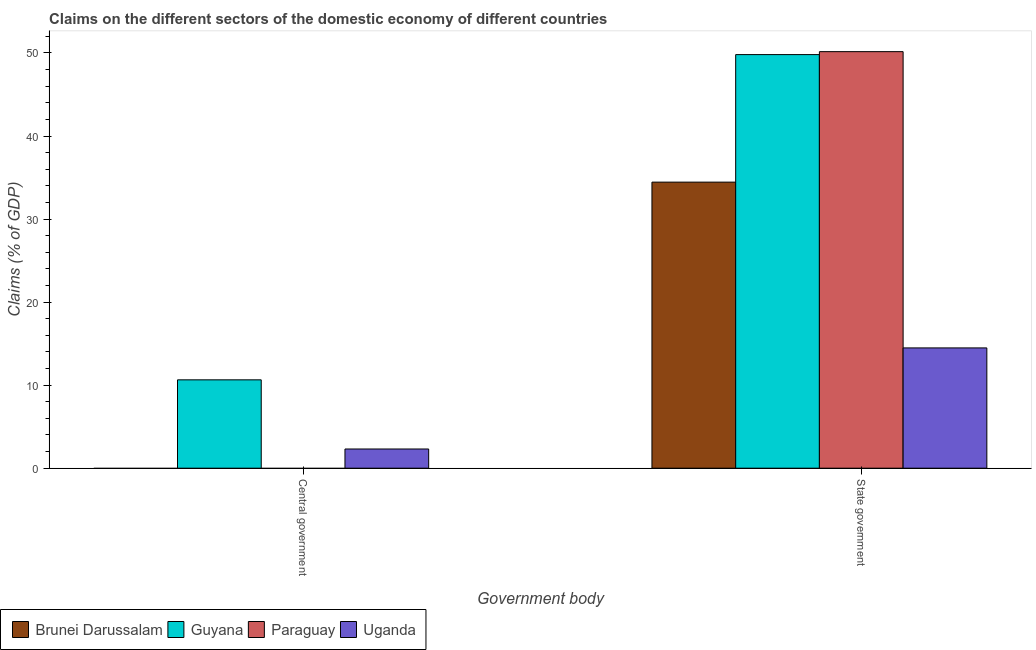How many different coloured bars are there?
Provide a short and direct response. 4. Are the number of bars per tick equal to the number of legend labels?
Your response must be concise. No. Are the number of bars on each tick of the X-axis equal?
Ensure brevity in your answer.  No. What is the label of the 2nd group of bars from the left?
Keep it short and to the point. State government. What is the claims on central government in Guyana?
Make the answer very short. 10.64. Across all countries, what is the maximum claims on state government?
Your answer should be very brief. 50.16. In which country was the claims on state government maximum?
Your answer should be very brief. Paraguay. What is the total claims on central government in the graph?
Keep it short and to the point. 12.95. What is the difference between the claims on central government in Uganda and that in Guyana?
Your answer should be compact. -8.33. What is the difference between the claims on state government in Paraguay and the claims on central government in Brunei Darussalam?
Your answer should be very brief. 50.16. What is the average claims on state government per country?
Your answer should be very brief. 37.22. What is the difference between the claims on state government and claims on central government in Guyana?
Provide a short and direct response. 39.16. What is the ratio of the claims on state government in Uganda to that in Guyana?
Make the answer very short. 0.29. How many bars are there?
Provide a succinct answer. 6. What is the difference between two consecutive major ticks on the Y-axis?
Make the answer very short. 10. What is the title of the graph?
Provide a short and direct response. Claims on the different sectors of the domestic economy of different countries. Does "Euro area" appear as one of the legend labels in the graph?
Give a very brief answer. No. What is the label or title of the X-axis?
Your answer should be very brief. Government body. What is the label or title of the Y-axis?
Provide a short and direct response. Claims (% of GDP). What is the Claims (% of GDP) in Brunei Darussalam in Central government?
Your response must be concise. 0. What is the Claims (% of GDP) of Guyana in Central government?
Give a very brief answer. 10.64. What is the Claims (% of GDP) of Uganda in Central government?
Keep it short and to the point. 2.31. What is the Claims (% of GDP) of Brunei Darussalam in State government?
Offer a very short reply. 34.44. What is the Claims (% of GDP) of Guyana in State government?
Offer a very short reply. 49.8. What is the Claims (% of GDP) of Paraguay in State government?
Make the answer very short. 50.16. What is the Claims (% of GDP) in Uganda in State government?
Your answer should be compact. 14.48. Across all Government body, what is the maximum Claims (% of GDP) in Brunei Darussalam?
Provide a short and direct response. 34.44. Across all Government body, what is the maximum Claims (% of GDP) in Guyana?
Keep it short and to the point. 49.8. Across all Government body, what is the maximum Claims (% of GDP) of Paraguay?
Keep it short and to the point. 50.16. Across all Government body, what is the maximum Claims (% of GDP) of Uganda?
Ensure brevity in your answer.  14.48. Across all Government body, what is the minimum Claims (% of GDP) of Guyana?
Give a very brief answer. 10.64. Across all Government body, what is the minimum Claims (% of GDP) of Uganda?
Offer a very short reply. 2.31. What is the total Claims (% of GDP) of Brunei Darussalam in the graph?
Your response must be concise. 34.44. What is the total Claims (% of GDP) in Guyana in the graph?
Offer a very short reply. 60.44. What is the total Claims (% of GDP) of Paraguay in the graph?
Offer a terse response. 50.16. What is the total Claims (% of GDP) in Uganda in the graph?
Make the answer very short. 16.8. What is the difference between the Claims (% of GDP) of Guyana in Central government and that in State government?
Your response must be concise. -39.16. What is the difference between the Claims (% of GDP) of Uganda in Central government and that in State government?
Your answer should be very brief. -12.17. What is the difference between the Claims (% of GDP) of Guyana in Central government and the Claims (% of GDP) of Paraguay in State government?
Your answer should be very brief. -39.52. What is the difference between the Claims (% of GDP) in Guyana in Central government and the Claims (% of GDP) in Uganda in State government?
Provide a short and direct response. -3.84. What is the average Claims (% of GDP) of Brunei Darussalam per Government body?
Provide a succinct answer. 17.22. What is the average Claims (% of GDP) of Guyana per Government body?
Your response must be concise. 30.22. What is the average Claims (% of GDP) in Paraguay per Government body?
Make the answer very short. 25.08. What is the average Claims (% of GDP) in Uganda per Government body?
Your answer should be compact. 8.4. What is the difference between the Claims (% of GDP) in Guyana and Claims (% of GDP) in Uganda in Central government?
Provide a succinct answer. 8.33. What is the difference between the Claims (% of GDP) of Brunei Darussalam and Claims (% of GDP) of Guyana in State government?
Your answer should be very brief. -15.36. What is the difference between the Claims (% of GDP) of Brunei Darussalam and Claims (% of GDP) of Paraguay in State government?
Make the answer very short. -15.71. What is the difference between the Claims (% of GDP) of Brunei Darussalam and Claims (% of GDP) of Uganda in State government?
Offer a very short reply. 19.96. What is the difference between the Claims (% of GDP) in Guyana and Claims (% of GDP) in Paraguay in State government?
Provide a succinct answer. -0.35. What is the difference between the Claims (% of GDP) of Guyana and Claims (% of GDP) of Uganda in State government?
Give a very brief answer. 35.32. What is the difference between the Claims (% of GDP) in Paraguay and Claims (% of GDP) in Uganda in State government?
Provide a short and direct response. 35.67. What is the ratio of the Claims (% of GDP) of Guyana in Central government to that in State government?
Your response must be concise. 0.21. What is the ratio of the Claims (% of GDP) of Uganda in Central government to that in State government?
Your answer should be very brief. 0.16. What is the difference between the highest and the second highest Claims (% of GDP) of Guyana?
Keep it short and to the point. 39.16. What is the difference between the highest and the second highest Claims (% of GDP) of Uganda?
Keep it short and to the point. 12.17. What is the difference between the highest and the lowest Claims (% of GDP) in Brunei Darussalam?
Make the answer very short. 34.44. What is the difference between the highest and the lowest Claims (% of GDP) in Guyana?
Keep it short and to the point. 39.16. What is the difference between the highest and the lowest Claims (% of GDP) in Paraguay?
Your response must be concise. 50.16. What is the difference between the highest and the lowest Claims (% of GDP) of Uganda?
Give a very brief answer. 12.17. 